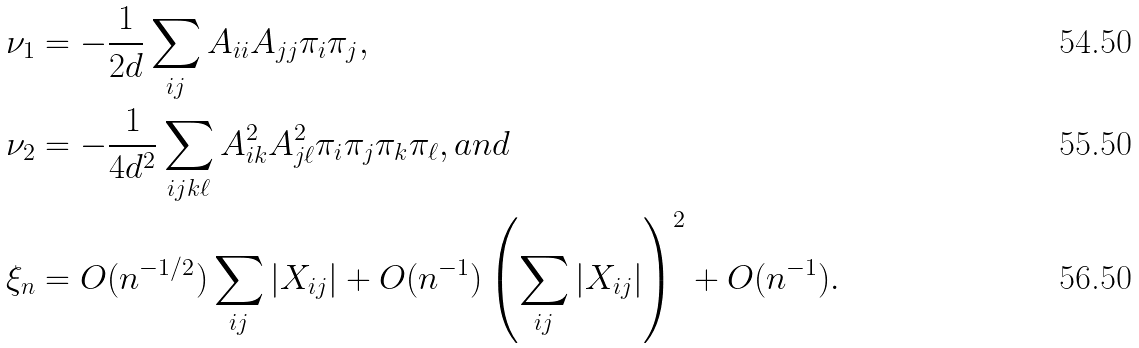Convert formula to latex. <formula><loc_0><loc_0><loc_500><loc_500>\nu _ { 1 } & = - \frac { 1 } { 2 d } \sum _ { i j } A _ { i i } A _ { j j } \pi _ { i } \pi _ { j } , \\ \nu _ { 2 } & = - \frac { 1 } { 4 d ^ { 2 } } \sum _ { i j k \ell } A _ { i k } ^ { 2 } A _ { j \ell } ^ { 2 } \pi _ { i } \pi _ { j } \pi _ { k } \pi _ { \ell } , a n d \\ \xi _ { n } & = O ( n ^ { - 1 / 2 } ) \sum _ { i j } | X _ { i j } | + O ( n ^ { - 1 } ) \left ( \sum _ { i j } | X _ { i j } | \right ) ^ { 2 } + O ( n ^ { - 1 } ) .</formula> 